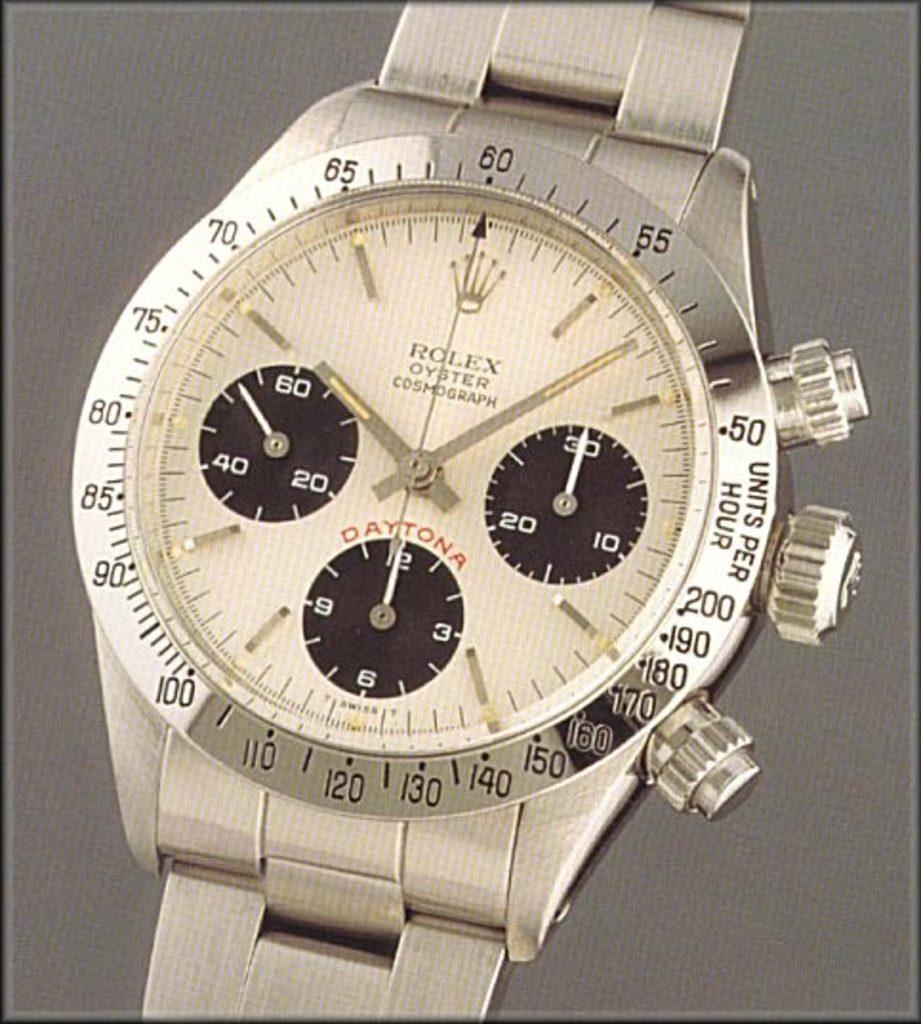What time is it?
Offer a very short reply. 10:07. What brand is this watch?
Your response must be concise. Rolex. 